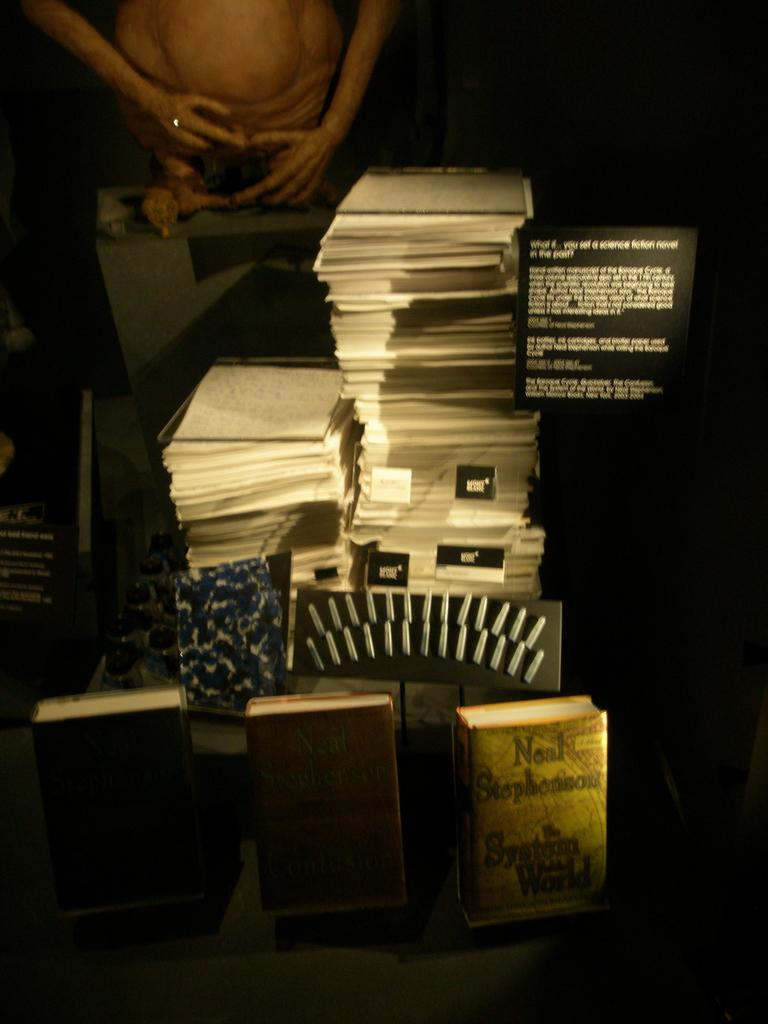<image>
Write a terse but informative summary of the picture. a book in front of a stack of papers that is by Neal Stephenson 